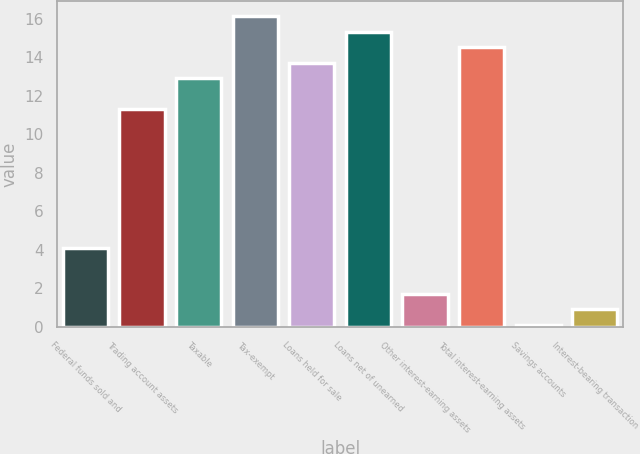Convert chart to OTSL. <chart><loc_0><loc_0><loc_500><loc_500><bar_chart><fcel>Federal funds sold and<fcel>Trading account assets<fcel>Taxable<fcel>Tax-exempt<fcel>Loans held for sale<fcel>Loans net of unearned<fcel>Other interest-earning assets<fcel>Total interest-earning assets<fcel>Savings accounts<fcel>Interest-bearing transaction<nl><fcel>4.11<fcel>11.31<fcel>12.91<fcel>16.11<fcel>13.71<fcel>15.31<fcel>1.71<fcel>14.51<fcel>0.11<fcel>0.91<nl></chart> 